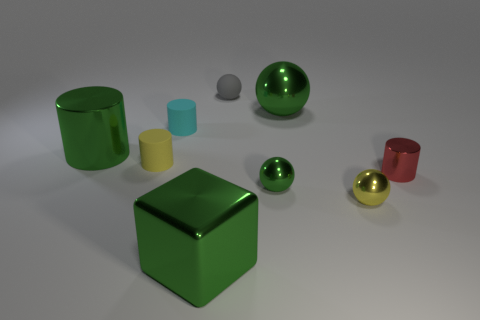Subtract all tiny green metal spheres. How many spheres are left? 3 Subtract all red cylinders. How many cylinders are left? 3 Subtract all cylinders. How many objects are left? 5 Add 1 yellow balls. How many objects exist? 10 Subtract all green cylinders. How many green balls are left? 2 Subtract 0 gray cylinders. How many objects are left? 9 Subtract 1 cubes. How many cubes are left? 0 Subtract all blue blocks. Subtract all brown cylinders. How many blocks are left? 1 Subtract all tiny gray balls. Subtract all yellow metal objects. How many objects are left? 7 Add 7 small yellow cylinders. How many small yellow cylinders are left? 8 